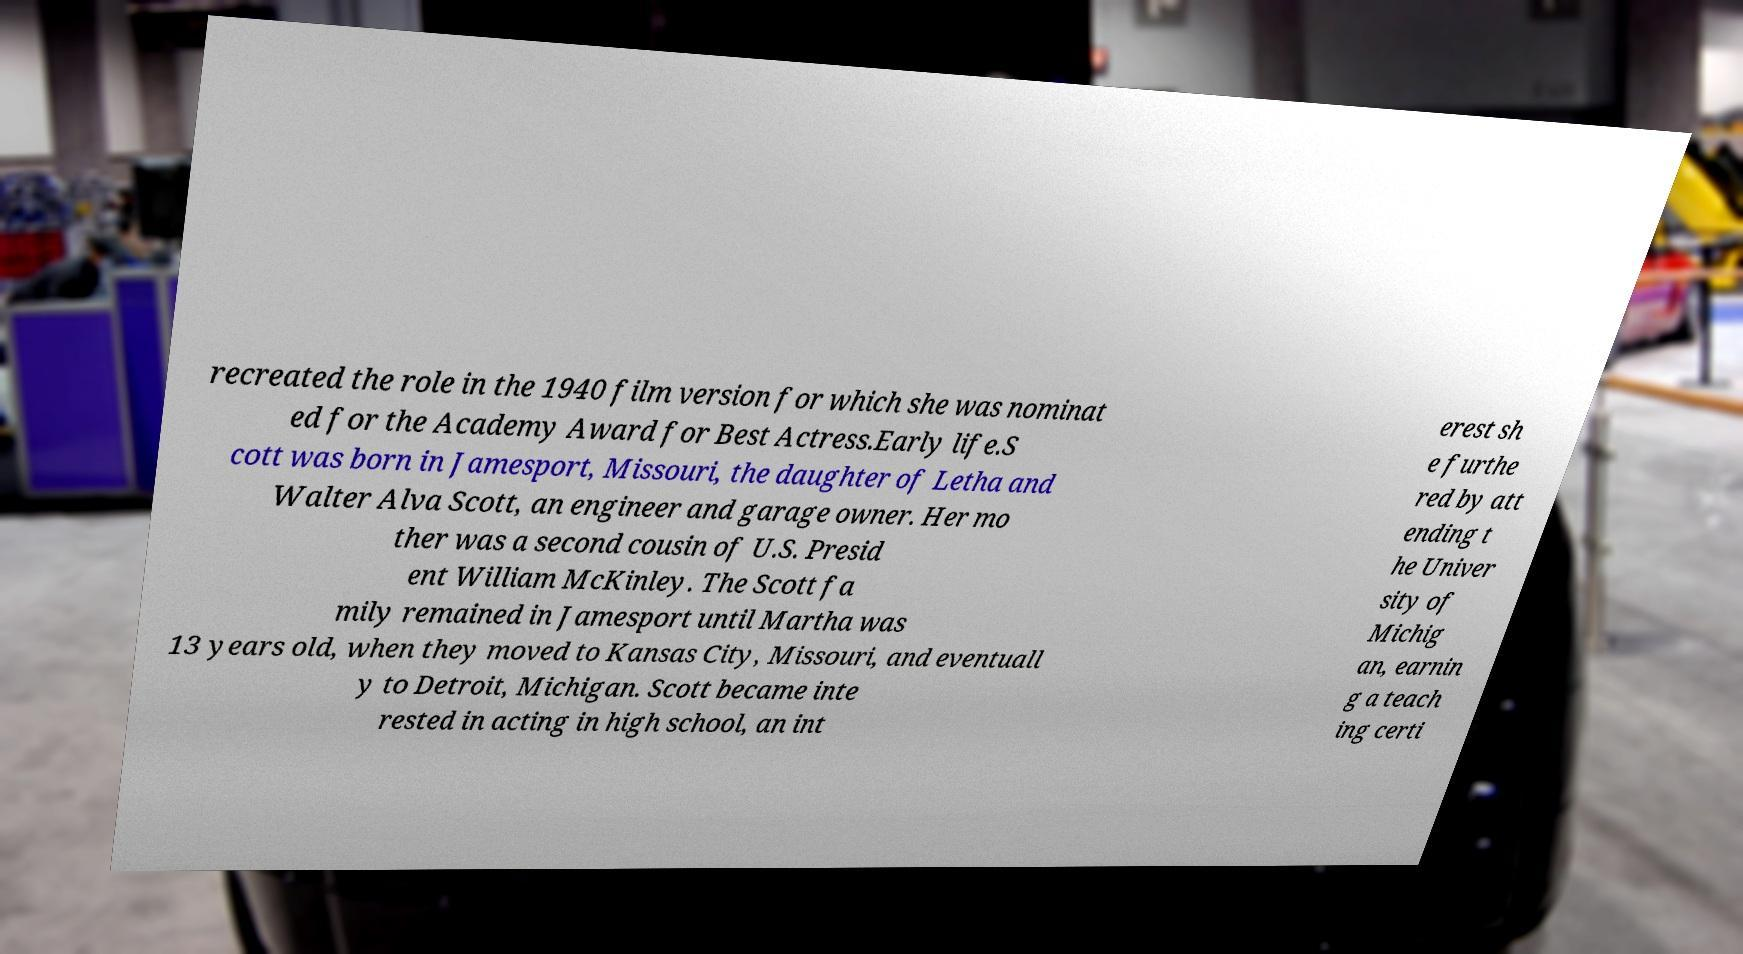Could you assist in decoding the text presented in this image and type it out clearly? recreated the role in the 1940 film version for which she was nominat ed for the Academy Award for Best Actress.Early life.S cott was born in Jamesport, Missouri, the daughter of Letha and Walter Alva Scott, an engineer and garage owner. Her mo ther was a second cousin of U.S. Presid ent William McKinley. The Scott fa mily remained in Jamesport until Martha was 13 years old, when they moved to Kansas City, Missouri, and eventuall y to Detroit, Michigan. Scott became inte rested in acting in high school, an int erest sh e furthe red by att ending t he Univer sity of Michig an, earnin g a teach ing certi 